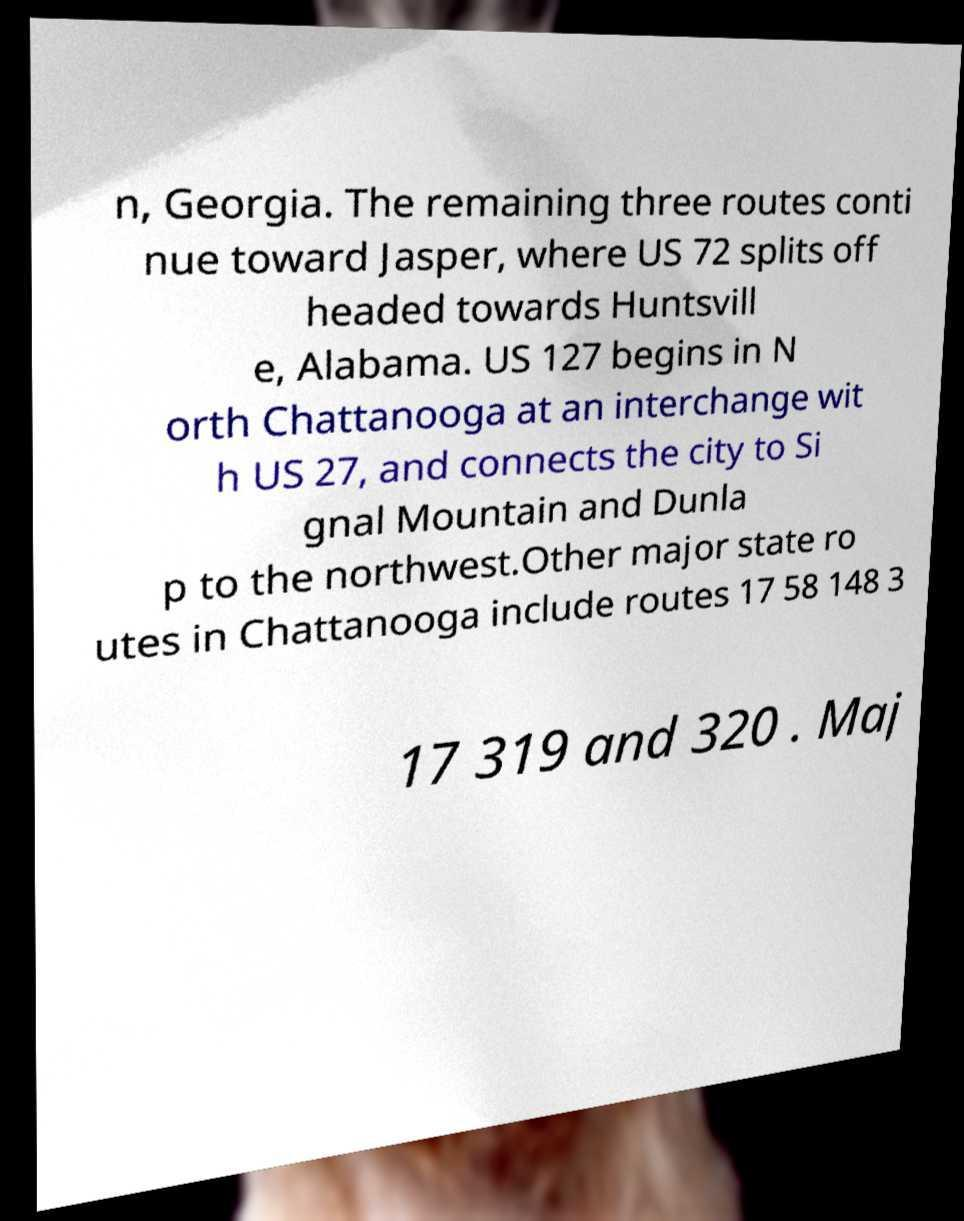For documentation purposes, I need the text within this image transcribed. Could you provide that? n, Georgia. The remaining three routes conti nue toward Jasper, where US 72 splits off headed towards Huntsvill e, Alabama. US 127 begins in N orth Chattanooga at an interchange wit h US 27, and connects the city to Si gnal Mountain and Dunla p to the northwest.Other major state ro utes in Chattanooga include routes 17 58 148 3 17 319 and 320 . Maj 